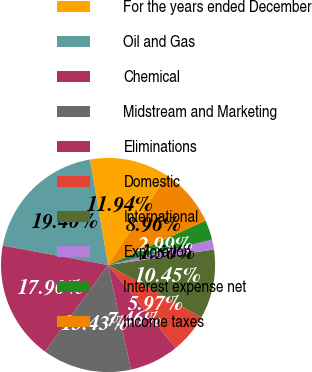<chart> <loc_0><loc_0><loc_500><loc_500><pie_chart><fcel>For the years ended December<fcel>Oil and Gas<fcel>Chemical<fcel>Midstream and Marketing<fcel>Eliminations<fcel>Domestic<fcel>International<fcel>Exploration<fcel>Interest expense net<fcel>Income taxes<nl><fcel>11.94%<fcel>19.4%<fcel>17.9%<fcel>13.43%<fcel>7.46%<fcel>5.97%<fcel>10.45%<fcel>1.5%<fcel>2.99%<fcel>8.96%<nl></chart> 